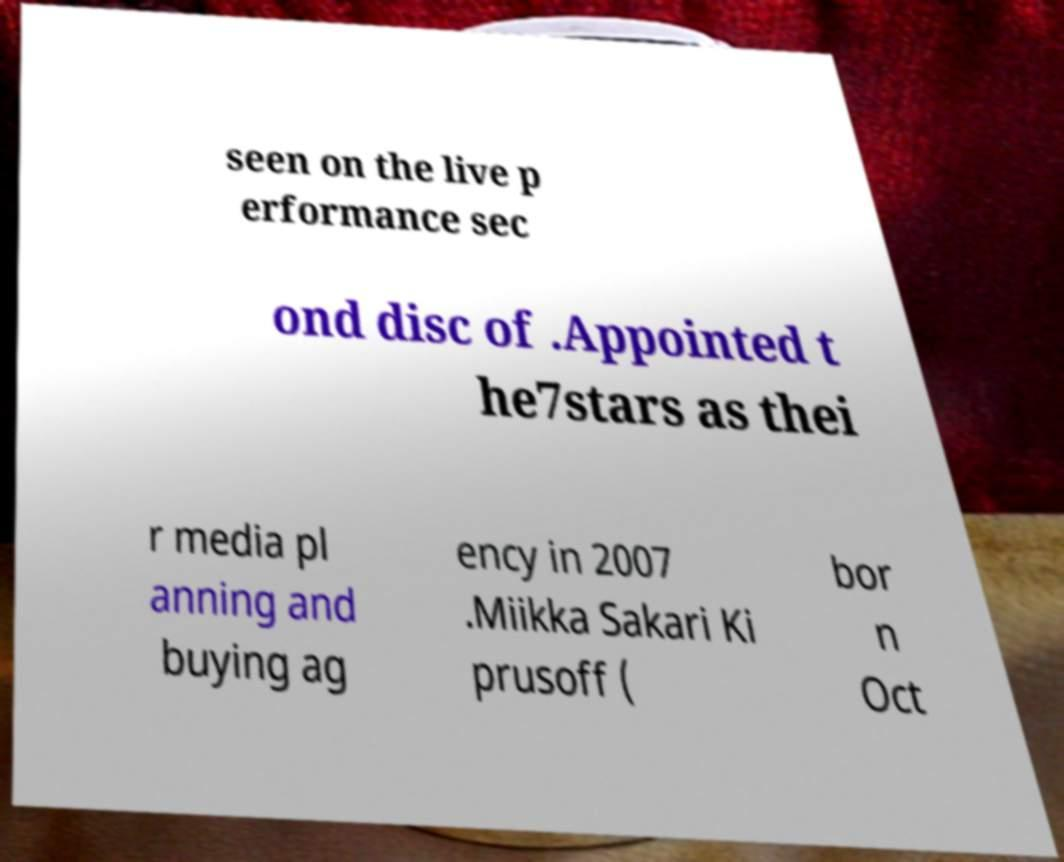Please read and relay the text visible in this image. What does it say? seen on the live p erformance sec ond disc of .Appointed t he7stars as thei r media pl anning and buying ag ency in 2007 .Miikka Sakari Ki prusoff ( bor n Oct 